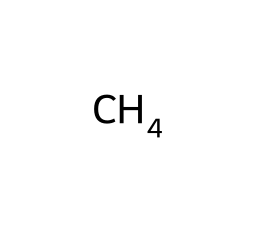What is the name of this chemical? The SMILES representation "C" indicates a single carbon atom, which corresponds to methane, the simplest hydrocarbon.
Answer: methane How many hydrogen atoms are bonded to the carbon in this molecule? Methane has one carbon atom that forms four single bonds with four hydrogen atoms, as per its molecular structure.
Answer: four What is the bond angle in methane? Methane has a tetrahedral geometry due to its four hydrogen atoms equally spaced around the central carbon atom, resulting in a bond angle of approximately 109.5 degrees.
Answer: 109.5 degrees What type of hybridization does the carbon in methane undergo? The carbon atom in methane uses sp3 hybridization to form four equivalent bonds with hydrogen, considering its tetrahedral shape.
Answer: sp3 Why is the molecular geometry of methane significant in 3D modeling? The tetrahedral geometry and consistent bond angles in methane enable accurate representations in 3D modeling, which is critical for simulating molecular interactions and predicting chemical behavior.
Answer: accurate representations What type of molecule is methane classified as? Methane is an alkane, a particular category of hydrocarbons characterized by single bonds between carbon atoms.
Answer: alkane 